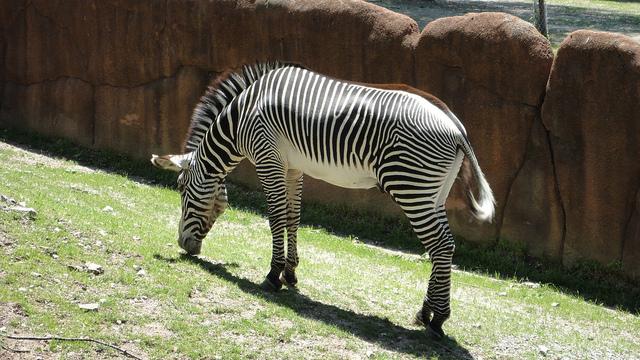How many zebras are shown in this picture?
Keep it brief. 1. Could that be the zebra's mother?
Answer briefly. Yes. Is the zebras head down?
Keep it brief. Yes. Is this a 4 legs animal?
Keep it brief. Yes. What is the zebra doing?
Quick response, please. Eating. How many zebras are there?
Concise answer only. 1. 